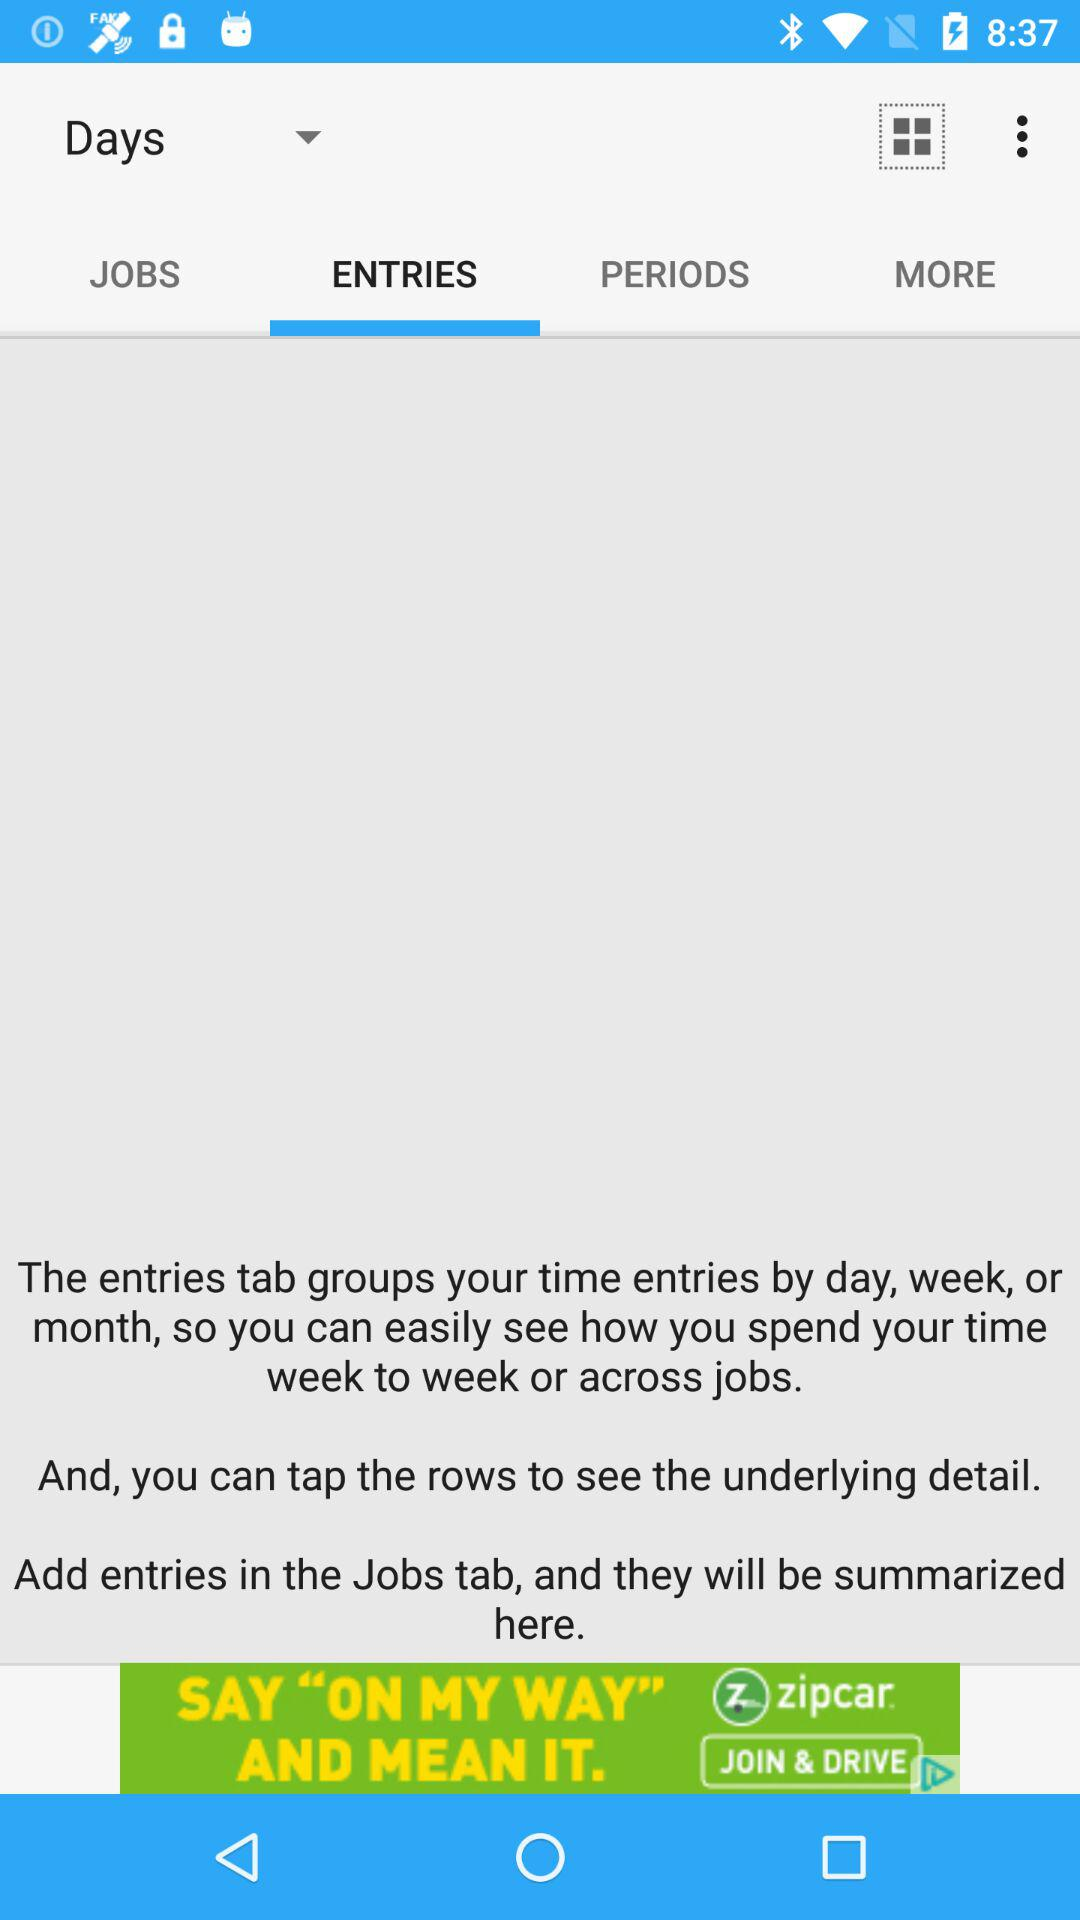Which tab is selected? The selected tab is "ENTRIES". 